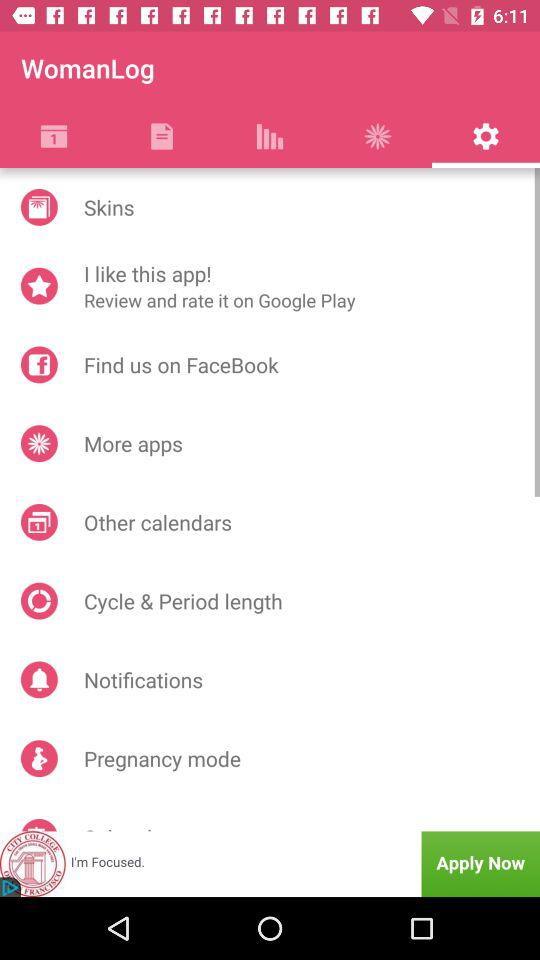What is the application name? The name of the application is "WomanLog". 